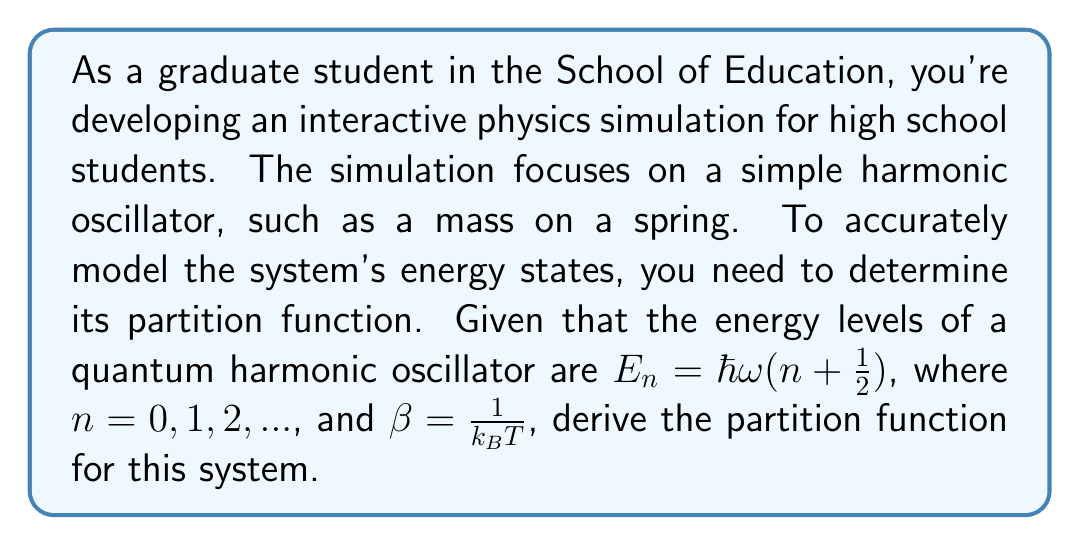Solve this math problem. Let's approach this step-by-step:

1) The partition function $Z$ is defined as the sum over all possible states:

   $Z = \sum_{n=0}^{\infty} e^{-\beta E_n}$

2) Substituting the energy levels:

   $Z = \sum_{n=0}^{\infty} e^{-\beta \hbar \omega (n + \frac{1}{2})}$

3) We can factor out the constant term:

   $Z = e^{-\beta \hbar \omega / 2} \sum_{n=0}^{\infty} e^{-\beta \hbar \omega n}$

4) Let $x = e^{-\beta \hbar \omega}$. Then our sum becomes:

   $Z = e^{-\beta \hbar \omega / 2} \sum_{n=0}^{\infty} x^n$

5) This is a geometric series with $|x| < 1$. The sum of this series is:

   $\sum_{n=0}^{\infty} x^n = \frac{1}{1-x}$

6) Substituting back:

   $Z = e^{-\beta \hbar \omega / 2} \frac{1}{1-e^{-\beta \hbar \omega}}$

7) We can simplify this further:

   $Z = \frac{e^{-\beta \hbar \omega / 2}}{1-e^{-\beta \hbar \omega}}$

This is the partition function for a quantum simple harmonic oscillator.
Answer: $Z = \frac{e^{-\beta \hbar \omega / 2}}{1-e^{-\beta \hbar \omega}}$ 